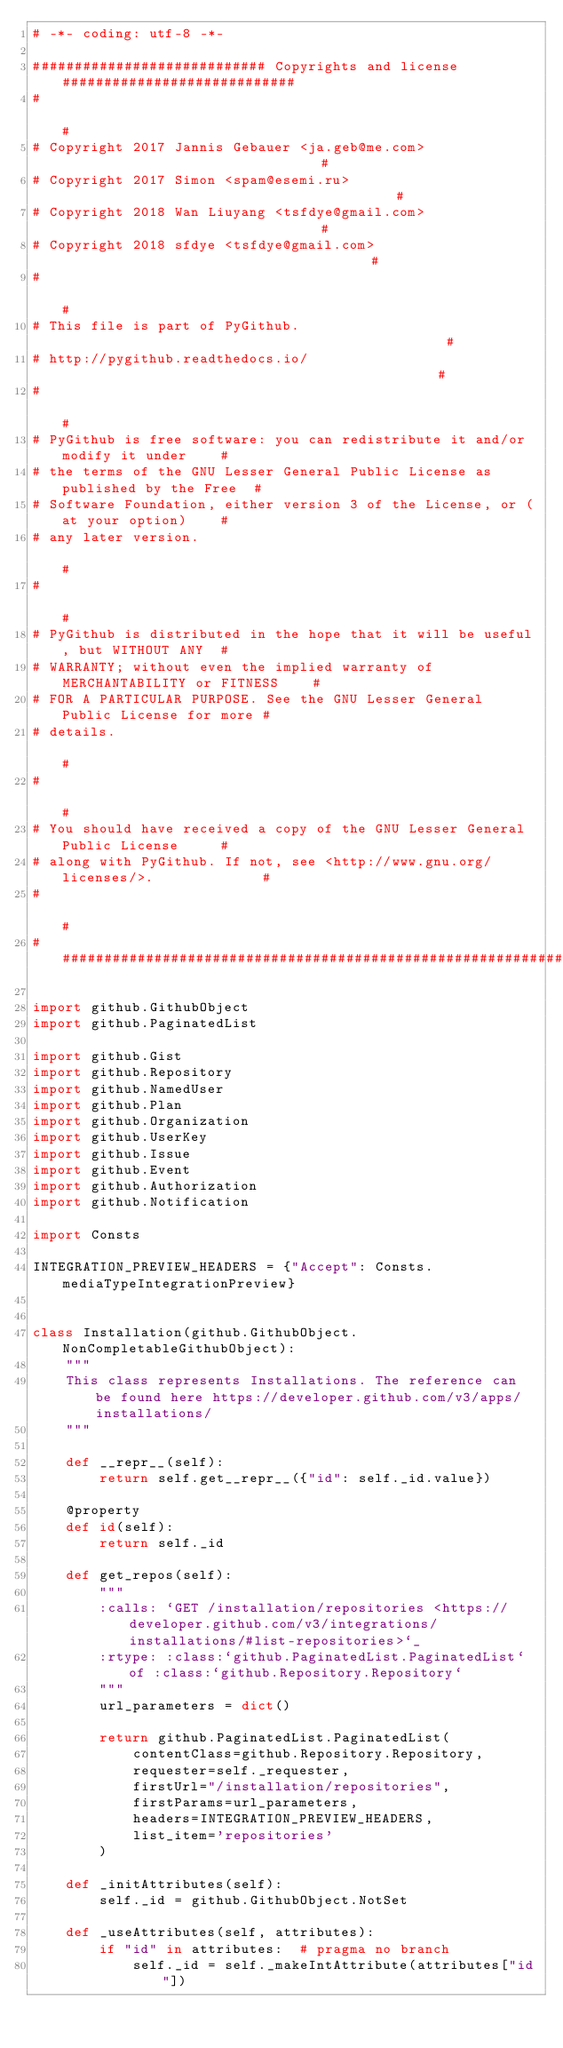<code> <loc_0><loc_0><loc_500><loc_500><_Python_># -*- coding: utf-8 -*-

############################ Copyrights and license ############################
#                                                                              #
# Copyright 2017 Jannis Gebauer <ja.geb@me.com>                                #
# Copyright 2017 Simon <spam@esemi.ru>                                         #
# Copyright 2018 Wan Liuyang <tsfdye@gmail.com>                                #
# Copyright 2018 sfdye <tsfdye@gmail.com>                                      #
#                                                                              #
# This file is part of PyGithub.                                               #
# http://pygithub.readthedocs.io/                                              #
#                                                                              #
# PyGithub is free software: you can redistribute it and/or modify it under    #
# the terms of the GNU Lesser General Public License as published by the Free  #
# Software Foundation, either version 3 of the License, or (at your option)    #
# any later version.                                                           #
#                                                                              #
# PyGithub is distributed in the hope that it will be useful, but WITHOUT ANY  #
# WARRANTY; without even the implied warranty of MERCHANTABILITY or FITNESS    #
# FOR A PARTICULAR PURPOSE. See the GNU Lesser General Public License for more #
# details.                                                                     #
#                                                                              #
# You should have received a copy of the GNU Lesser General Public License     #
# along with PyGithub. If not, see <http://www.gnu.org/licenses/>.             #
#                                                                              #
################################################################################

import github.GithubObject
import github.PaginatedList

import github.Gist
import github.Repository
import github.NamedUser
import github.Plan
import github.Organization
import github.UserKey
import github.Issue
import github.Event
import github.Authorization
import github.Notification

import Consts

INTEGRATION_PREVIEW_HEADERS = {"Accept": Consts.mediaTypeIntegrationPreview}


class Installation(github.GithubObject.NonCompletableGithubObject):
    """
    This class represents Installations. The reference can be found here https://developer.github.com/v3/apps/installations/
    """

    def __repr__(self):
        return self.get__repr__({"id": self._id.value})

    @property
    def id(self):
        return self._id

    def get_repos(self):
        """
        :calls: `GET /installation/repositories <https://developer.github.com/v3/integrations/installations/#list-repositories>`_
        :rtype: :class:`github.PaginatedList.PaginatedList` of :class:`github.Repository.Repository`
        """
        url_parameters = dict()

        return github.PaginatedList.PaginatedList(
            contentClass=github.Repository.Repository,
            requester=self._requester,
            firstUrl="/installation/repositories",
            firstParams=url_parameters,
            headers=INTEGRATION_PREVIEW_HEADERS,
            list_item='repositories'
        )

    def _initAttributes(self):
        self._id = github.GithubObject.NotSet

    def _useAttributes(self, attributes):
        if "id" in attributes:  # pragma no branch
            self._id = self._makeIntAttribute(attributes["id"])
</code> 